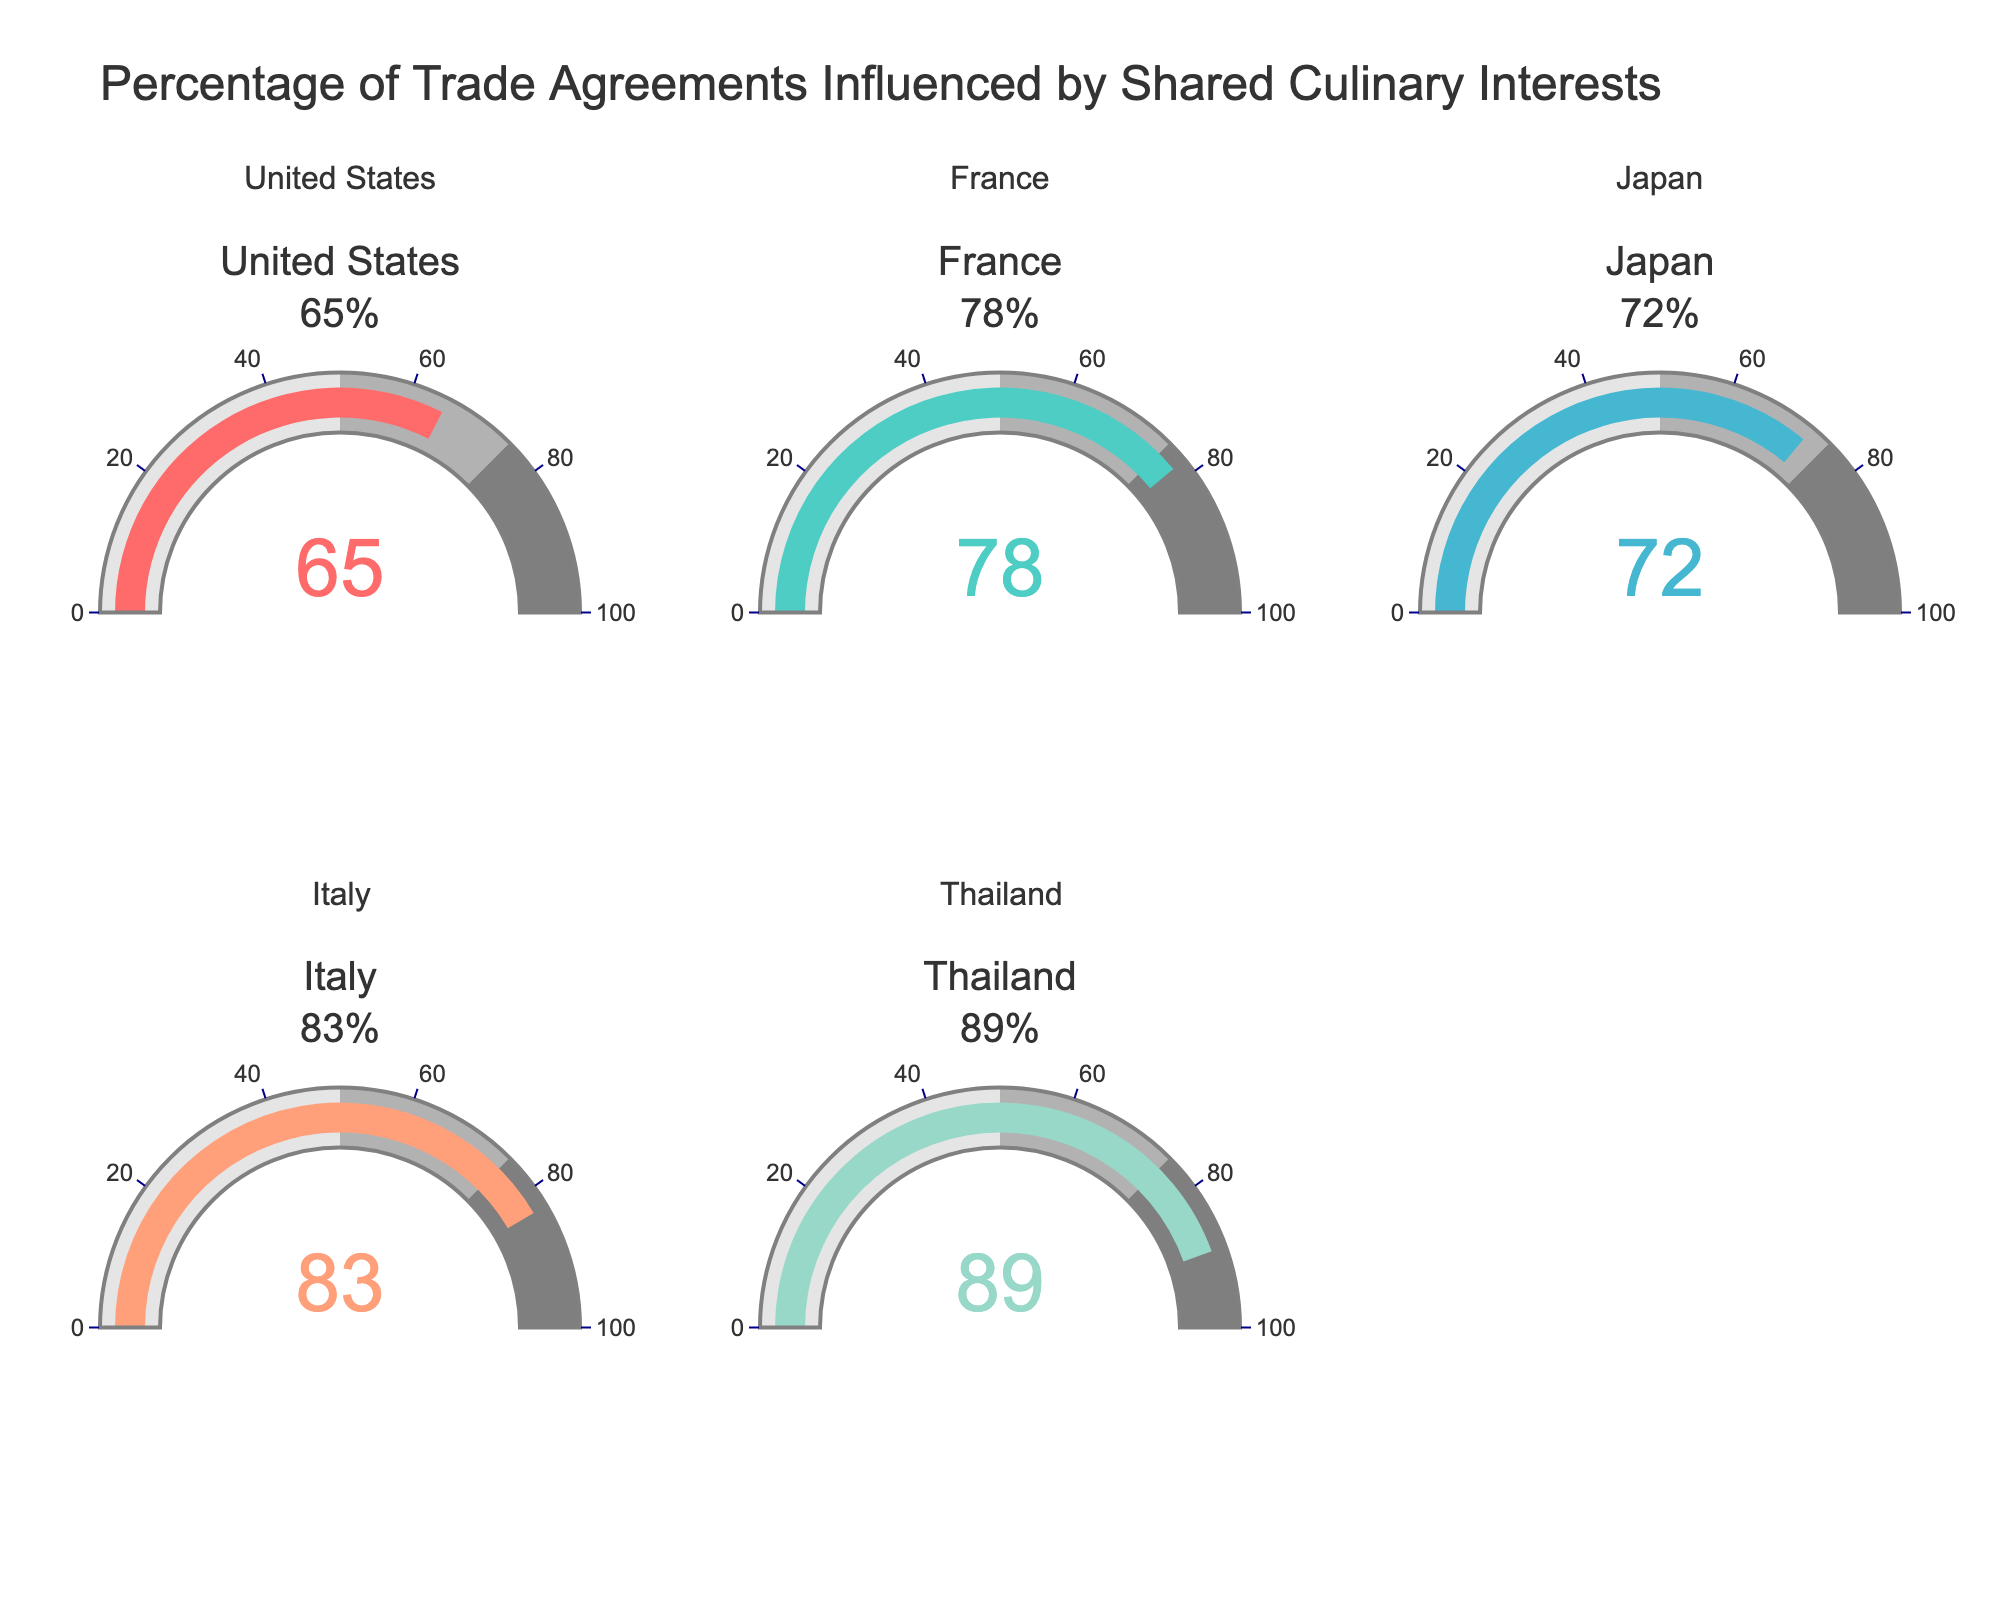What's the title of the figure? The title is prominently displayed at the top of the figure. It reads "Percentage of Trade Agreements Influenced by Shared Culinary Interests."
Answer: Percentage of Trade Agreements Influenced by Shared Culinary Interests How many countries are represented in the figure? The figure contains five gauges, each representing a different country, so there are five countries in total.
Answer: Five Which country has the highest percentage of trade agreements influenced by shared culinary interests? By analyzing the values on the gauges, Thailand has the highest percentage at 89%.
Answer: Thailand Which country has the lowest percentage of trade agreements influenced by shared culinary interests? By observing the values on the gauges, the United States has the lowest percentage at 65%.
Answer: United States What are the percentages for France and Japan collectively? France has a percentage of 78% and Japan has 72%. Adding these together gives 78% + 72% = 150%.
Answer: 150% Is the percentage for Italy greater than the percentage for Japan? Italy's gauge shows 83% while Japan's shows 72%. Since 83% is greater than 72%, Italy's percentage is indeed higher.
Answer: Yes Calculate the average percentage of trade agreements influenced by shared culinary interests for the five countries. The percentages are 65%, 78%, 72%, 83%, and 89%. Adding these gives 387%. Dividing by the number of countries (5) gives an average of 77.4%.
Answer: 77.4% Which country's gauge has the color '#4ECDC4'? The gauge colors are assigned in the order of the countries. The second gauge represents France, which has the color '#4ECDC4'.
Answer: France How much higher is Thailand's percentage compared to the United States? Thailand has a percentage of 89%, and the United States has 65%. The difference is 89% - 65% = 24%.
Answer: 24% Do any countries fall below 70% in their percentage of trade agreements influenced by shared culinary interests? By looking at the gauges, the United States is the only country with a percentage below 70%, at 65%.
Answer: Yes 